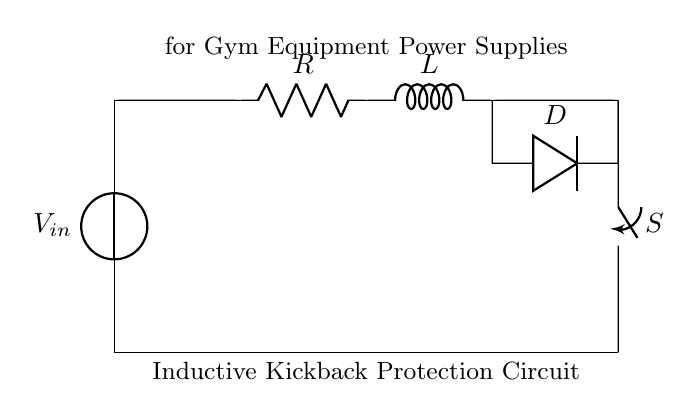What type of circuit is represented? The circuit is an inductive kickback protection circuit, which is indicated in the label of the diagram. It is designed to protect the circuit from voltage spikes caused by an inductive load.
Answer: inductive kickback protection circuit What is the component labeled "L"? The component labeled "L" represents an inductor in the circuit. It is specifically designed to store energy in a magnetic field when current flows through it.
Answer: inductor What does the switch "S" do? The switch "S" controls the flow of current in the circuit. When the switch is closed, current can flow through the circuit to the inductor.
Answer: controls current flow Which component prevents reverse current? The component labeled "D" is a diode, which is used to prevent reverse current from flowing when the inductor discharges. The diode allows current to flow in one direction only.
Answer: diode What happens when the switch is opened? When the switch is opened, the current flowing through the inductor tries to maintain its flow, which can generate a high voltage spike; the diode "D" provides a path for this current, preventing damage to other circuit components.
Answer: current generates voltage spike What is the function of the resistor "R"? The resistor "R" limits the current that can flow through the circuit, which can help to prevent excessive current from damaging the inductor and other components.
Answer: limits current What does the inductor do when the switch is closed? When the switch is closed, the inductor stores energy by building a magnetic field as current flows through it. This energy will be released when the switch is opened.
Answer: stores energy 